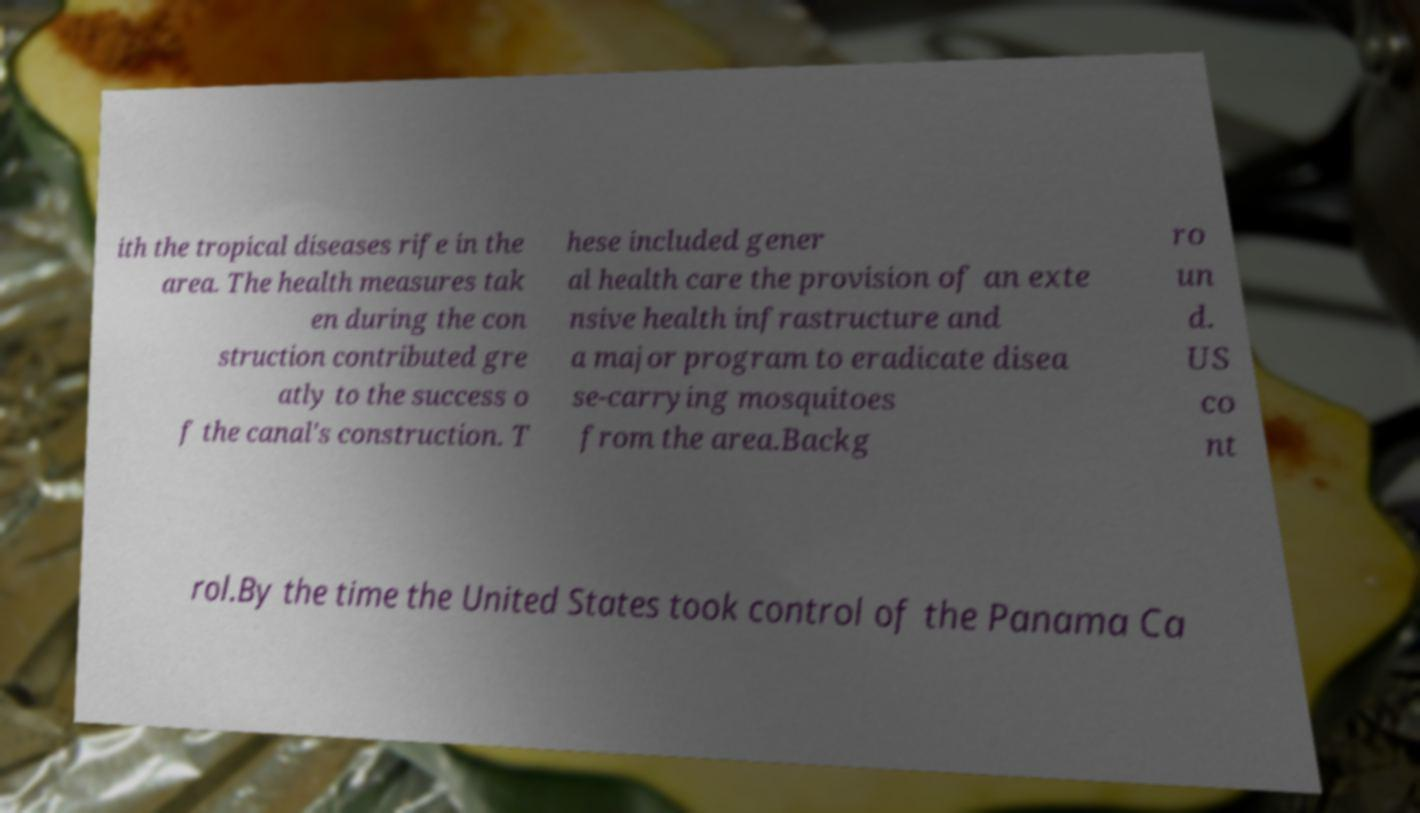Please read and relay the text visible in this image. What does it say? ith the tropical diseases rife in the area. The health measures tak en during the con struction contributed gre atly to the success o f the canal's construction. T hese included gener al health care the provision of an exte nsive health infrastructure and a major program to eradicate disea se-carrying mosquitoes from the area.Backg ro un d. US co nt rol.By the time the United States took control of the Panama Ca 